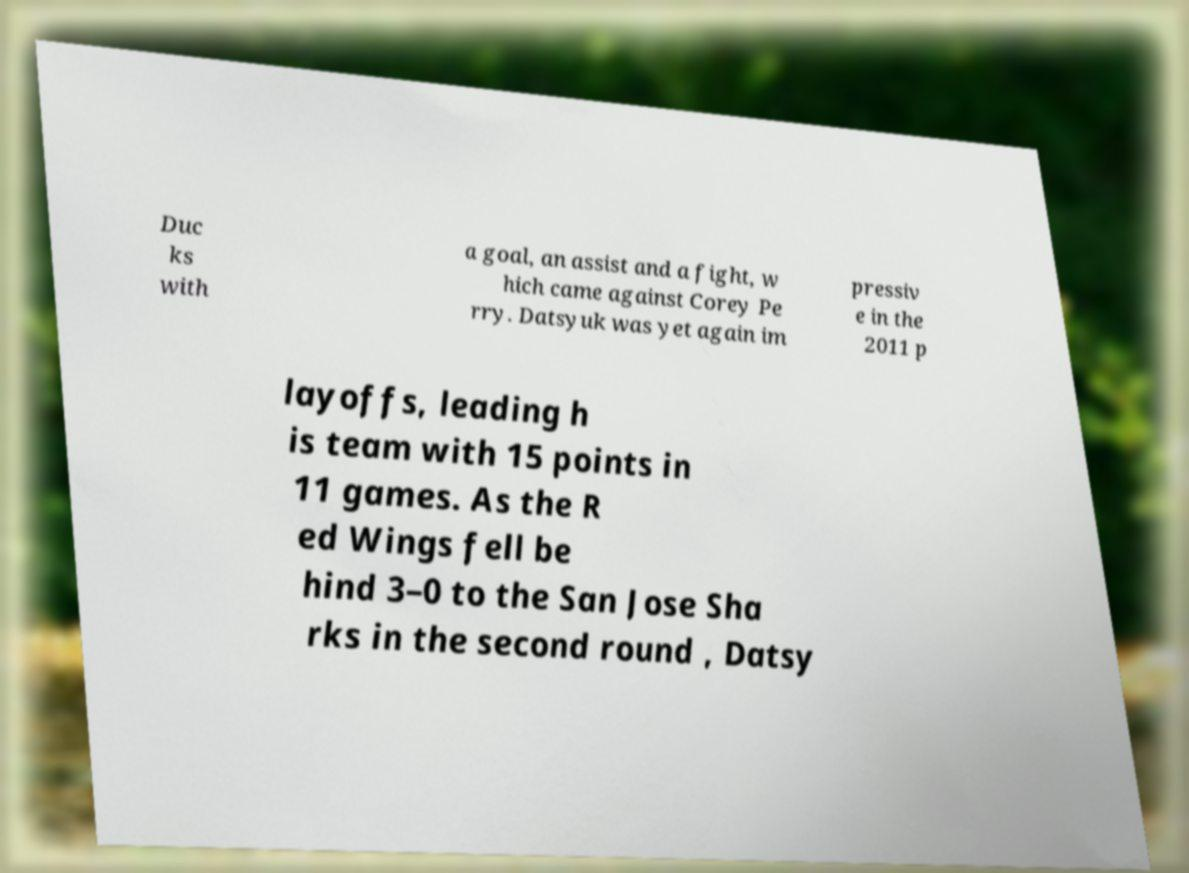For documentation purposes, I need the text within this image transcribed. Could you provide that? Duc ks with a goal, an assist and a fight, w hich came against Corey Pe rry. Datsyuk was yet again im pressiv e in the 2011 p layoffs, leading h is team with 15 points in 11 games. As the R ed Wings fell be hind 3–0 to the San Jose Sha rks in the second round , Datsy 